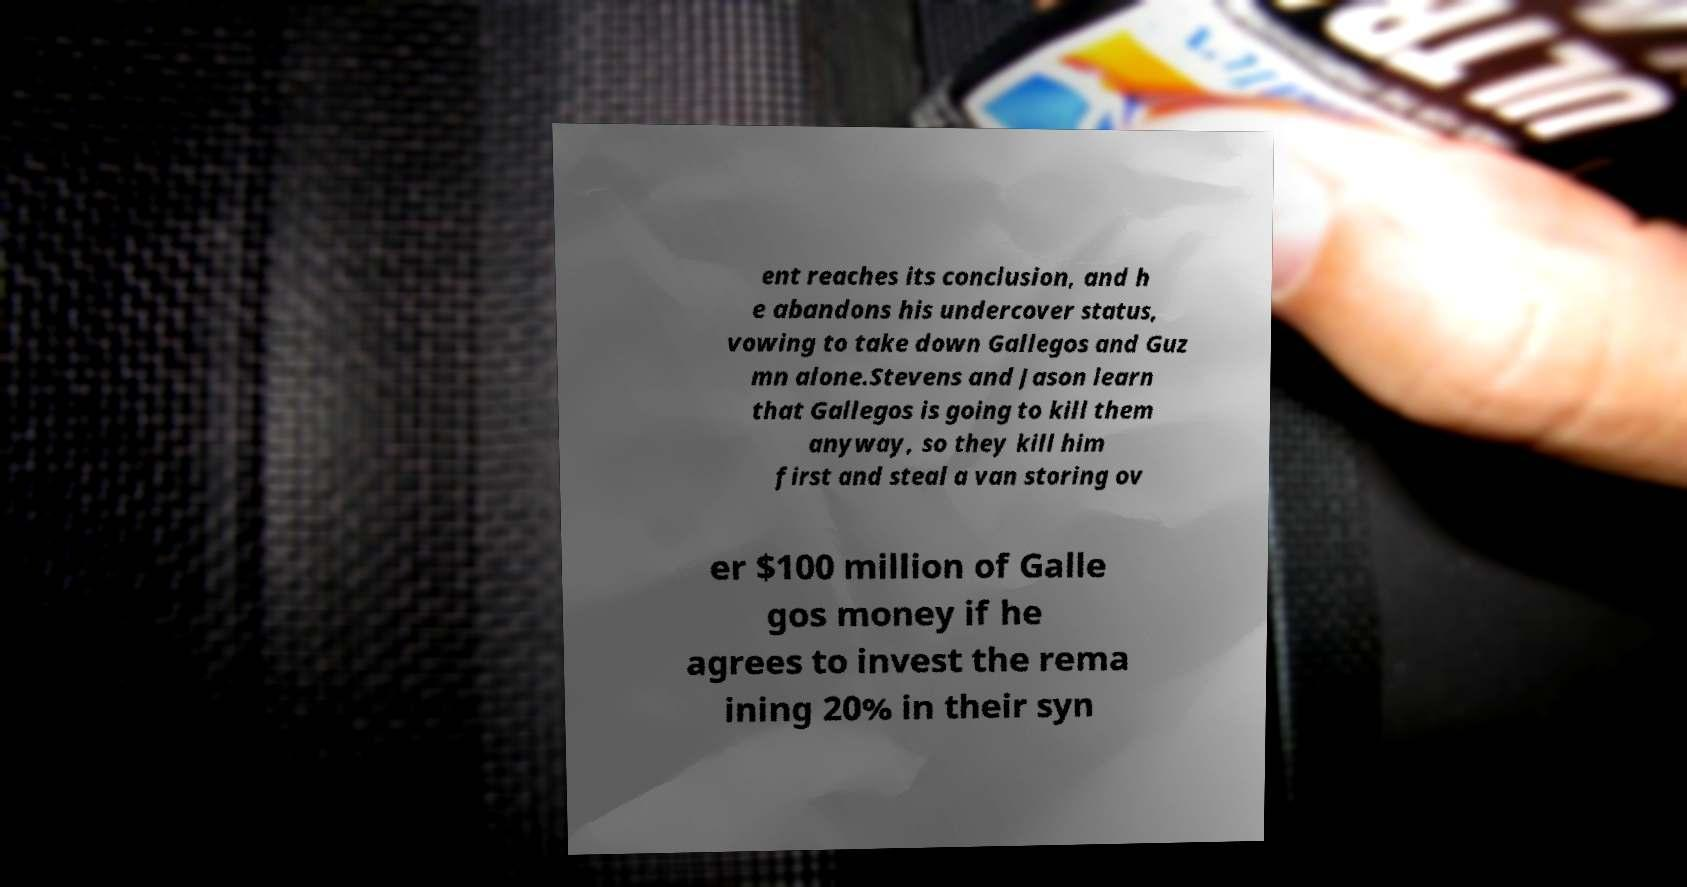Can you read and provide the text displayed in the image?This photo seems to have some interesting text. Can you extract and type it out for me? ent reaches its conclusion, and h e abandons his undercover status, vowing to take down Gallegos and Guz mn alone.Stevens and Jason learn that Gallegos is going to kill them anyway, so they kill him first and steal a van storing ov er $100 million of Galle gos money if he agrees to invest the rema ining 20% in their syn 